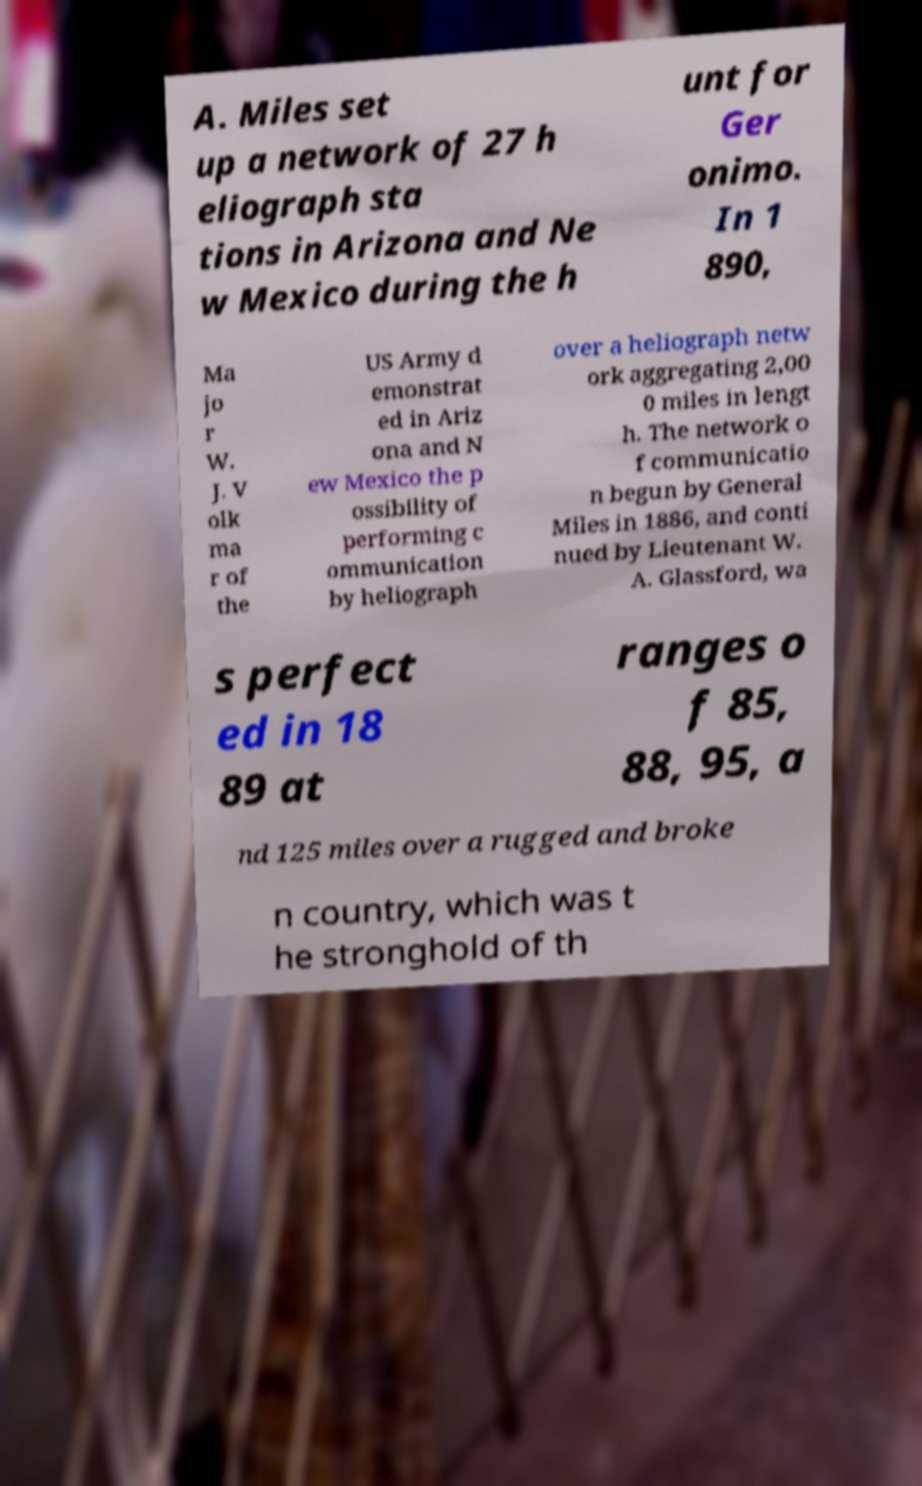Please identify and transcribe the text found in this image. A. Miles set up a network of 27 h eliograph sta tions in Arizona and Ne w Mexico during the h unt for Ger onimo. In 1 890, Ma jo r W. J. V olk ma r of the US Army d emonstrat ed in Ariz ona and N ew Mexico the p ossibility of performing c ommunication by heliograph over a heliograph netw ork aggregating 2,00 0 miles in lengt h. The network o f communicatio n begun by General Miles in 1886, and conti nued by Lieutenant W. A. Glassford, wa s perfect ed in 18 89 at ranges o f 85, 88, 95, a nd 125 miles over a rugged and broke n country, which was t he stronghold of th 